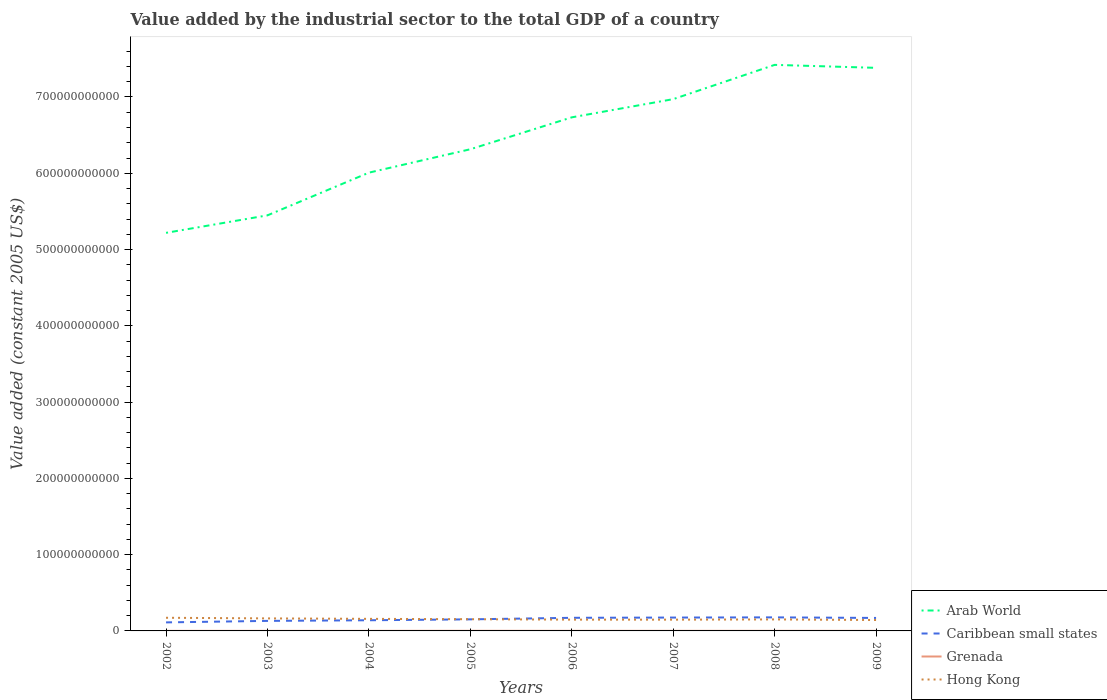Does the line corresponding to Arab World intersect with the line corresponding to Caribbean small states?
Keep it short and to the point. No. Is the number of lines equal to the number of legend labels?
Provide a short and direct response. Yes. Across all years, what is the maximum value added by the industrial sector in Hong Kong?
Keep it short and to the point. 1.43e+1. In which year was the value added by the industrial sector in Arab World maximum?
Keep it short and to the point. 2002. What is the total value added by the industrial sector in Hong Kong in the graph?
Make the answer very short. -3.16e+08. What is the difference between the highest and the second highest value added by the industrial sector in Caribbean small states?
Provide a succinct answer. 6.58e+09. Is the value added by the industrial sector in Grenada strictly greater than the value added by the industrial sector in Arab World over the years?
Offer a terse response. Yes. How many lines are there?
Your answer should be compact. 4. How many years are there in the graph?
Provide a succinct answer. 8. What is the difference between two consecutive major ticks on the Y-axis?
Ensure brevity in your answer.  1.00e+11. Are the values on the major ticks of Y-axis written in scientific E-notation?
Your answer should be compact. No. Does the graph contain grids?
Provide a short and direct response. No. Where does the legend appear in the graph?
Give a very brief answer. Bottom right. How many legend labels are there?
Keep it short and to the point. 4. What is the title of the graph?
Offer a very short reply. Value added by the industrial sector to the total GDP of a country. What is the label or title of the X-axis?
Provide a succinct answer. Years. What is the label or title of the Y-axis?
Ensure brevity in your answer.  Value added (constant 2005 US$). What is the Value added (constant 2005 US$) of Arab World in 2002?
Your answer should be compact. 5.22e+11. What is the Value added (constant 2005 US$) in Caribbean small states in 2002?
Ensure brevity in your answer.  1.12e+1. What is the Value added (constant 2005 US$) of Grenada in 2002?
Your answer should be compact. 8.91e+07. What is the Value added (constant 2005 US$) in Hong Kong in 2002?
Offer a very short reply. 1.72e+1. What is the Value added (constant 2005 US$) of Arab World in 2003?
Keep it short and to the point. 5.45e+11. What is the Value added (constant 2005 US$) in Caribbean small states in 2003?
Make the answer very short. 1.32e+1. What is the Value added (constant 2005 US$) of Grenada in 2003?
Provide a succinct answer. 1.01e+08. What is the Value added (constant 2005 US$) of Hong Kong in 2003?
Provide a succinct answer. 1.64e+1. What is the Value added (constant 2005 US$) in Arab World in 2004?
Offer a terse response. 6.01e+11. What is the Value added (constant 2005 US$) of Caribbean small states in 2004?
Ensure brevity in your answer.  1.40e+1. What is the Value added (constant 2005 US$) in Grenada in 2004?
Your answer should be compact. 1.01e+08. What is the Value added (constant 2005 US$) of Hong Kong in 2004?
Your answer should be compact. 1.58e+1. What is the Value added (constant 2005 US$) of Arab World in 2005?
Your response must be concise. 6.31e+11. What is the Value added (constant 2005 US$) of Caribbean small states in 2005?
Your answer should be very brief. 1.52e+1. What is the Value added (constant 2005 US$) of Grenada in 2005?
Ensure brevity in your answer.  1.59e+08. What is the Value added (constant 2005 US$) of Hong Kong in 2005?
Ensure brevity in your answer.  1.54e+1. What is the Value added (constant 2005 US$) in Arab World in 2006?
Your response must be concise. 6.73e+11. What is the Value added (constant 2005 US$) of Caribbean small states in 2006?
Give a very brief answer. 1.72e+1. What is the Value added (constant 2005 US$) in Grenada in 2006?
Your answer should be very brief. 1.25e+08. What is the Value added (constant 2005 US$) in Hong Kong in 2006?
Keep it short and to the point. 1.48e+1. What is the Value added (constant 2005 US$) of Arab World in 2007?
Offer a very short reply. 6.97e+11. What is the Value added (constant 2005 US$) of Caribbean small states in 2007?
Your answer should be very brief. 1.75e+1. What is the Value added (constant 2005 US$) in Grenada in 2007?
Ensure brevity in your answer.  1.23e+08. What is the Value added (constant 2005 US$) in Hong Kong in 2007?
Offer a very short reply. 1.48e+1. What is the Value added (constant 2005 US$) in Arab World in 2008?
Provide a succinct answer. 7.42e+11. What is the Value added (constant 2005 US$) of Caribbean small states in 2008?
Your answer should be very brief. 1.78e+1. What is the Value added (constant 2005 US$) of Grenada in 2008?
Your answer should be compact. 1.17e+08. What is the Value added (constant 2005 US$) of Hong Kong in 2008?
Ensure brevity in your answer.  1.51e+1. What is the Value added (constant 2005 US$) in Arab World in 2009?
Provide a succinct answer. 7.38e+11. What is the Value added (constant 2005 US$) of Caribbean small states in 2009?
Provide a succinct answer. 1.70e+1. What is the Value added (constant 2005 US$) of Grenada in 2009?
Ensure brevity in your answer.  9.46e+07. What is the Value added (constant 2005 US$) in Hong Kong in 2009?
Your response must be concise. 1.43e+1. Across all years, what is the maximum Value added (constant 2005 US$) in Arab World?
Give a very brief answer. 7.42e+11. Across all years, what is the maximum Value added (constant 2005 US$) of Caribbean small states?
Provide a short and direct response. 1.78e+1. Across all years, what is the maximum Value added (constant 2005 US$) in Grenada?
Keep it short and to the point. 1.59e+08. Across all years, what is the maximum Value added (constant 2005 US$) of Hong Kong?
Make the answer very short. 1.72e+1. Across all years, what is the minimum Value added (constant 2005 US$) of Arab World?
Make the answer very short. 5.22e+11. Across all years, what is the minimum Value added (constant 2005 US$) in Caribbean small states?
Offer a terse response. 1.12e+1. Across all years, what is the minimum Value added (constant 2005 US$) of Grenada?
Your answer should be compact. 8.91e+07. Across all years, what is the minimum Value added (constant 2005 US$) in Hong Kong?
Provide a short and direct response. 1.43e+1. What is the total Value added (constant 2005 US$) in Arab World in the graph?
Your response must be concise. 5.15e+12. What is the total Value added (constant 2005 US$) of Caribbean small states in the graph?
Your answer should be very brief. 1.23e+11. What is the total Value added (constant 2005 US$) of Grenada in the graph?
Keep it short and to the point. 9.10e+08. What is the total Value added (constant 2005 US$) in Hong Kong in the graph?
Provide a short and direct response. 1.24e+11. What is the difference between the Value added (constant 2005 US$) in Arab World in 2002 and that in 2003?
Your answer should be compact. -2.29e+1. What is the difference between the Value added (constant 2005 US$) of Caribbean small states in 2002 and that in 2003?
Provide a succinct answer. -1.97e+09. What is the difference between the Value added (constant 2005 US$) in Grenada in 2002 and that in 2003?
Provide a short and direct response. -1.23e+07. What is the difference between the Value added (constant 2005 US$) of Hong Kong in 2002 and that in 2003?
Give a very brief answer. 8.12e+08. What is the difference between the Value added (constant 2005 US$) of Arab World in 2002 and that in 2004?
Provide a succinct answer. -7.89e+1. What is the difference between the Value added (constant 2005 US$) in Caribbean small states in 2002 and that in 2004?
Give a very brief answer. -2.80e+09. What is the difference between the Value added (constant 2005 US$) in Grenada in 2002 and that in 2004?
Ensure brevity in your answer.  -1.16e+07. What is the difference between the Value added (constant 2005 US$) of Hong Kong in 2002 and that in 2004?
Your answer should be very brief. 1.42e+09. What is the difference between the Value added (constant 2005 US$) in Arab World in 2002 and that in 2005?
Make the answer very short. -1.10e+11. What is the difference between the Value added (constant 2005 US$) in Caribbean small states in 2002 and that in 2005?
Make the answer very short. -3.99e+09. What is the difference between the Value added (constant 2005 US$) of Grenada in 2002 and that in 2005?
Your answer should be compact. -6.98e+07. What is the difference between the Value added (constant 2005 US$) of Hong Kong in 2002 and that in 2005?
Ensure brevity in your answer.  1.88e+09. What is the difference between the Value added (constant 2005 US$) in Arab World in 2002 and that in 2006?
Make the answer very short. -1.51e+11. What is the difference between the Value added (constant 2005 US$) of Caribbean small states in 2002 and that in 2006?
Make the answer very short. -6.01e+09. What is the difference between the Value added (constant 2005 US$) of Grenada in 2002 and that in 2006?
Your answer should be compact. -3.59e+07. What is the difference between the Value added (constant 2005 US$) of Hong Kong in 2002 and that in 2006?
Provide a short and direct response. 2.43e+09. What is the difference between the Value added (constant 2005 US$) in Arab World in 2002 and that in 2007?
Give a very brief answer. -1.75e+11. What is the difference between the Value added (constant 2005 US$) in Caribbean small states in 2002 and that in 2007?
Your answer should be compact. -6.33e+09. What is the difference between the Value added (constant 2005 US$) in Grenada in 2002 and that in 2007?
Your answer should be very brief. -3.36e+07. What is the difference between the Value added (constant 2005 US$) of Hong Kong in 2002 and that in 2007?
Keep it short and to the point. 2.47e+09. What is the difference between the Value added (constant 2005 US$) of Arab World in 2002 and that in 2008?
Offer a very short reply. -2.20e+11. What is the difference between the Value added (constant 2005 US$) in Caribbean small states in 2002 and that in 2008?
Your answer should be very brief. -6.58e+09. What is the difference between the Value added (constant 2005 US$) of Grenada in 2002 and that in 2008?
Give a very brief answer. -2.82e+07. What is the difference between the Value added (constant 2005 US$) in Hong Kong in 2002 and that in 2008?
Your answer should be compact. 2.16e+09. What is the difference between the Value added (constant 2005 US$) of Arab World in 2002 and that in 2009?
Give a very brief answer. -2.16e+11. What is the difference between the Value added (constant 2005 US$) of Caribbean small states in 2002 and that in 2009?
Provide a short and direct response. -5.84e+09. What is the difference between the Value added (constant 2005 US$) of Grenada in 2002 and that in 2009?
Give a very brief answer. -5.55e+06. What is the difference between the Value added (constant 2005 US$) of Hong Kong in 2002 and that in 2009?
Your answer should be compact. 2.94e+09. What is the difference between the Value added (constant 2005 US$) of Arab World in 2003 and that in 2004?
Make the answer very short. -5.60e+1. What is the difference between the Value added (constant 2005 US$) in Caribbean small states in 2003 and that in 2004?
Give a very brief answer. -8.28e+08. What is the difference between the Value added (constant 2005 US$) in Grenada in 2003 and that in 2004?
Keep it short and to the point. 6.55e+05. What is the difference between the Value added (constant 2005 US$) in Hong Kong in 2003 and that in 2004?
Keep it short and to the point. 6.04e+08. What is the difference between the Value added (constant 2005 US$) in Arab World in 2003 and that in 2005?
Keep it short and to the point. -8.67e+1. What is the difference between the Value added (constant 2005 US$) in Caribbean small states in 2003 and that in 2005?
Keep it short and to the point. -2.02e+09. What is the difference between the Value added (constant 2005 US$) of Grenada in 2003 and that in 2005?
Offer a very short reply. -5.76e+07. What is the difference between the Value added (constant 2005 US$) of Hong Kong in 2003 and that in 2005?
Provide a short and direct response. 1.07e+09. What is the difference between the Value added (constant 2005 US$) of Arab World in 2003 and that in 2006?
Provide a short and direct response. -1.28e+11. What is the difference between the Value added (constant 2005 US$) in Caribbean small states in 2003 and that in 2006?
Offer a terse response. -4.04e+09. What is the difference between the Value added (constant 2005 US$) in Grenada in 2003 and that in 2006?
Your answer should be compact. -2.36e+07. What is the difference between the Value added (constant 2005 US$) of Hong Kong in 2003 and that in 2006?
Offer a very short reply. 1.61e+09. What is the difference between the Value added (constant 2005 US$) of Arab World in 2003 and that in 2007?
Your answer should be compact. -1.52e+11. What is the difference between the Value added (constant 2005 US$) in Caribbean small states in 2003 and that in 2007?
Give a very brief answer. -4.36e+09. What is the difference between the Value added (constant 2005 US$) of Grenada in 2003 and that in 2007?
Keep it short and to the point. -2.13e+07. What is the difference between the Value added (constant 2005 US$) in Hong Kong in 2003 and that in 2007?
Make the answer very short. 1.66e+09. What is the difference between the Value added (constant 2005 US$) in Arab World in 2003 and that in 2008?
Provide a short and direct response. -1.97e+11. What is the difference between the Value added (constant 2005 US$) of Caribbean small states in 2003 and that in 2008?
Your answer should be compact. -4.61e+09. What is the difference between the Value added (constant 2005 US$) in Grenada in 2003 and that in 2008?
Your answer should be compact. -1.59e+07. What is the difference between the Value added (constant 2005 US$) in Hong Kong in 2003 and that in 2008?
Offer a terse response. 1.35e+09. What is the difference between the Value added (constant 2005 US$) of Arab World in 2003 and that in 2009?
Make the answer very short. -1.93e+11. What is the difference between the Value added (constant 2005 US$) of Caribbean small states in 2003 and that in 2009?
Offer a terse response. -3.86e+09. What is the difference between the Value added (constant 2005 US$) in Grenada in 2003 and that in 2009?
Offer a terse response. 6.71e+06. What is the difference between the Value added (constant 2005 US$) of Hong Kong in 2003 and that in 2009?
Ensure brevity in your answer.  2.13e+09. What is the difference between the Value added (constant 2005 US$) of Arab World in 2004 and that in 2005?
Keep it short and to the point. -3.07e+1. What is the difference between the Value added (constant 2005 US$) in Caribbean small states in 2004 and that in 2005?
Make the answer very short. -1.19e+09. What is the difference between the Value added (constant 2005 US$) in Grenada in 2004 and that in 2005?
Give a very brief answer. -5.82e+07. What is the difference between the Value added (constant 2005 US$) in Hong Kong in 2004 and that in 2005?
Your answer should be compact. 4.62e+08. What is the difference between the Value added (constant 2005 US$) of Arab World in 2004 and that in 2006?
Provide a short and direct response. -7.25e+1. What is the difference between the Value added (constant 2005 US$) in Caribbean small states in 2004 and that in 2006?
Ensure brevity in your answer.  -3.21e+09. What is the difference between the Value added (constant 2005 US$) of Grenada in 2004 and that in 2006?
Make the answer very short. -2.43e+07. What is the difference between the Value added (constant 2005 US$) of Hong Kong in 2004 and that in 2006?
Ensure brevity in your answer.  1.01e+09. What is the difference between the Value added (constant 2005 US$) of Arab World in 2004 and that in 2007?
Make the answer very short. -9.64e+1. What is the difference between the Value added (constant 2005 US$) in Caribbean small states in 2004 and that in 2007?
Provide a succinct answer. -3.53e+09. What is the difference between the Value added (constant 2005 US$) in Grenada in 2004 and that in 2007?
Keep it short and to the point. -2.20e+07. What is the difference between the Value added (constant 2005 US$) in Hong Kong in 2004 and that in 2007?
Offer a very short reply. 1.06e+09. What is the difference between the Value added (constant 2005 US$) in Arab World in 2004 and that in 2008?
Make the answer very short. -1.41e+11. What is the difference between the Value added (constant 2005 US$) in Caribbean small states in 2004 and that in 2008?
Offer a very short reply. -3.78e+09. What is the difference between the Value added (constant 2005 US$) in Grenada in 2004 and that in 2008?
Your response must be concise. -1.66e+07. What is the difference between the Value added (constant 2005 US$) in Hong Kong in 2004 and that in 2008?
Provide a short and direct response. 7.42e+08. What is the difference between the Value added (constant 2005 US$) of Arab World in 2004 and that in 2009?
Your response must be concise. -1.37e+11. What is the difference between the Value added (constant 2005 US$) of Caribbean small states in 2004 and that in 2009?
Offer a very short reply. -3.04e+09. What is the difference between the Value added (constant 2005 US$) in Grenada in 2004 and that in 2009?
Make the answer very short. 6.06e+06. What is the difference between the Value added (constant 2005 US$) of Hong Kong in 2004 and that in 2009?
Provide a succinct answer. 1.53e+09. What is the difference between the Value added (constant 2005 US$) of Arab World in 2005 and that in 2006?
Ensure brevity in your answer.  -4.18e+1. What is the difference between the Value added (constant 2005 US$) of Caribbean small states in 2005 and that in 2006?
Offer a terse response. -2.02e+09. What is the difference between the Value added (constant 2005 US$) in Grenada in 2005 and that in 2006?
Keep it short and to the point. 3.39e+07. What is the difference between the Value added (constant 2005 US$) of Hong Kong in 2005 and that in 2006?
Make the answer very short. 5.48e+08. What is the difference between the Value added (constant 2005 US$) of Arab World in 2005 and that in 2007?
Provide a short and direct response. -6.57e+1. What is the difference between the Value added (constant 2005 US$) in Caribbean small states in 2005 and that in 2007?
Your answer should be compact. -2.34e+09. What is the difference between the Value added (constant 2005 US$) in Grenada in 2005 and that in 2007?
Your answer should be very brief. 3.62e+07. What is the difference between the Value added (constant 2005 US$) in Hong Kong in 2005 and that in 2007?
Offer a terse response. 5.95e+08. What is the difference between the Value added (constant 2005 US$) of Arab World in 2005 and that in 2008?
Your response must be concise. -1.11e+11. What is the difference between the Value added (constant 2005 US$) in Caribbean small states in 2005 and that in 2008?
Ensure brevity in your answer.  -2.59e+09. What is the difference between the Value added (constant 2005 US$) in Grenada in 2005 and that in 2008?
Keep it short and to the point. 4.16e+07. What is the difference between the Value added (constant 2005 US$) in Hong Kong in 2005 and that in 2008?
Provide a succinct answer. 2.79e+08. What is the difference between the Value added (constant 2005 US$) in Arab World in 2005 and that in 2009?
Provide a short and direct response. -1.07e+11. What is the difference between the Value added (constant 2005 US$) of Caribbean small states in 2005 and that in 2009?
Provide a short and direct response. -1.85e+09. What is the difference between the Value added (constant 2005 US$) of Grenada in 2005 and that in 2009?
Offer a very short reply. 6.43e+07. What is the difference between the Value added (constant 2005 US$) in Hong Kong in 2005 and that in 2009?
Your answer should be very brief. 1.06e+09. What is the difference between the Value added (constant 2005 US$) in Arab World in 2006 and that in 2007?
Provide a succinct answer. -2.39e+1. What is the difference between the Value added (constant 2005 US$) of Caribbean small states in 2006 and that in 2007?
Provide a short and direct response. -3.19e+08. What is the difference between the Value added (constant 2005 US$) of Grenada in 2006 and that in 2007?
Make the answer very short. 2.30e+06. What is the difference between the Value added (constant 2005 US$) in Hong Kong in 2006 and that in 2007?
Your answer should be compact. 4.72e+07. What is the difference between the Value added (constant 2005 US$) of Arab World in 2006 and that in 2008?
Offer a terse response. -6.88e+1. What is the difference between the Value added (constant 2005 US$) in Caribbean small states in 2006 and that in 2008?
Ensure brevity in your answer.  -5.71e+08. What is the difference between the Value added (constant 2005 US$) in Grenada in 2006 and that in 2008?
Offer a very short reply. 7.68e+06. What is the difference between the Value added (constant 2005 US$) of Hong Kong in 2006 and that in 2008?
Your answer should be very brief. -2.69e+08. What is the difference between the Value added (constant 2005 US$) of Arab World in 2006 and that in 2009?
Make the answer very short. -6.49e+1. What is the difference between the Value added (constant 2005 US$) of Caribbean small states in 2006 and that in 2009?
Your response must be concise. 1.75e+08. What is the difference between the Value added (constant 2005 US$) of Grenada in 2006 and that in 2009?
Your answer should be compact. 3.03e+07. What is the difference between the Value added (constant 2005 US$) in Hong Kong in 2006 and that in 2009?
Your response must be concise. 5.16e+08. What is the difference between the Value added (constant 2005 US$) of Arab World in 2007 and that in 2008?
Give a very brief answer. -4.49e+1. What is the difference between the Value added (constant 2005 US$) of Caribbean small states in 2007 and that in 2008?
Give a very brief answer. -2.52e+08. What is the difference between the Value added (constant 2005 US$) of Grenada in 2007 and that in 2008?
Provide a short and direct response. 5.39e+06. What is the difference between the Value added (constant 2005 US$) of Hong Kong in 2007 and that in 2008?
Offer a very short reply. -3.16e+08. What is the difference between the Value added (constant 2005 US$) of Arab World in 2007 and that in 2009?
Offer a terse response. -4.10e+1. What is the difference between the Value added (constant 2005 US$) in Caribbean small states in 2007 and that in 2009?
Your answer should be very brief. 4.93e+08. What is the difference between the Value added (constant 2005 US$) in Grenada in 2007 and that in 2009?
Keep it short and to the point. 2.80e+07. What is the difference between the Value added (constant 2005 US$) of Hong Kong in 2007 and that in 2009?
Offer a terse response. 4.69e+08. What is the difference between the Value added (constant 2005 US$) in Arab World in 2008 and that in 2009?
Offer a very short reply. 3.89e+09. What is the difference between the Value added (constant 2005 US$) of Caribbean small states in 2008 and that in 2009?
Provide a short and direct response. 7.46e+08. What is the difference between the Value added (constant 2005 US$) in Grenada in 2008 and that in 2009?
Offer a very short reply. 2.27e+07. What is the difference between the Value added (constant 2005 US$) in Hong Kong in 2008 and that in 2009?
Make the answer very short. 7.85e+08. What is the difference between the Value added (constant 2005 US$) of Arab World in 2002 and the Value added (constant 2005 US$) of Caribbean small states in 2003?
Give a very brief answer. 5.09e+11. What is the difference between the Value added (constant 2005 US$) of Arab World in 2002 and the Value added (constant 2005 US$) of Grenada in 2003?
Give a very brief answer. 5.22e+11. What is the difference between the Value added (constant 2005 US$) in Arab World in 2002 and the Value added (constant 2005 US$) in Hong Kong in 2003?
Your answer should be compact. 5.05e+11. What is the difference between the Value added (constant 2005 US$) in Caribbean small states in 2002 and the Value added (constant 2005 US$) in Grenada in 2003?
Ensure brevity in your answer.  1.11e+1. What is the difference between the Value added (constant 2005 US$) in Caribbean small states in 2002 and the Value added (constant 2005 US$) in Hong Kong in 2003?
Offer a very short reply. -5.24e+09. What is the difference between the Value added (constant 2005 US$) of Grenada in 2002 and the Value added (constant 2005 US$) of Hong Kong in 2003?
Give a very brief answer. -1.63e+1. What is the difference between the Value added (constant 2005 US$) of Arab World in 2002 and the Value added (constant 2005 US$) of Caribbean small states in 2004?
Offer a very short reply. 5.08e+11. What is the difference between the Value added (constant 2005 US$) in Arab World in 2002 and the Value added (constant 2005 US$) in Grenada in 2004?
Provide a succinct answer. 5.22e+11. What is the difference between the Value added (constant 2005 US$) in Arab World in 2002 and the Value added (constant 2005 US$) in Hong Kong in 2004?
Keep it short and to the point. 5.06e+11. What is the difference between the Value added (constant 2005 US$) of Caribbean small states in 2002 and the Value added (constant 2005 US$) of Grenada in 2004?
Make the answer very short. 1.11e+1. What is the difference between the Value added (constant 2005 US$) in Caribbean small states in 2002 and the Value added (constant 2005 US$) in Hong Kong in 2004?
Your response must be concise. -4.63e+09. What is the difference between the Value added (constant 2005 US$) in Grenada in 2002 and the Value added (constant 2005 US$) in Hong Kong in 2004?
Make the answer very short. -1.57e+1. What is the difference between the Value added (constant 2005 US$) in Arab World in 2002 and the Value added (constant 2005 US$) in Caribbean small states in 2005?
Your answer should be very brief. 5.07e+11. What is the difference between the Value added (constant 2005 US$) in Arab World in 2002 and the Value added (constant 2005 US$) in Grenada in 2005?
Provide a short and direct response. 5.22e+11. What is the difference between the Value added (constant 2005 US$) in Arab World in 2002 and the Value added (constant 2005 US$) in Hong Kong in 2005?
Give a very brief answer. 5.07e+11. What is the difference between the Value added (constant 2005 US$) in Caribbean small states in 2002 and the Value added (constant 2005 US$) in Grenada in 2005?
Provide a succinct answer. 1.10e+1. What is the difference between the Value added (constant 2005 US$) of Caribbean small states in 2002 and the Value added (constant 2005 US$) of Hong Kong in 2005?
Your response must be concise. -4.17e+09. What is the difference between the Value added (constant 2005 US$) in Grenada in 2002 and the Value added (constant 2005 US$) in Hong Kong in 2005?
Offer a very short reply. -1.53e+1. What is the difference between the Value added (constant 2005 US$) of Arab World in 2002 and the Value added (constant 2005 US$) of Caribbean small states in 2006?
Give a very brief answer. 5.05e+11. What is the difference between the Value added (constant 2005 US$) of Arab World in 2002 and the Value added (constant 2005 US$) of Grenada in 2006?
Keep it short and to the point. 5.22e+11. What is the difference between the Value added (constant 2005 US$) in Arab World in 2002 and the Value added (constant 2005 US$) in Hong Kong in 2006?
Offer a very short reply. 5.07e+11. What is the difference between the Value added (constant 2005 US$) of Caribbean small states in 2002 and the Value added (constant 2005 US$) of Grenada in 2006?
Provide a short and direct response. 1.11e+1. What is the difference between the Value added (constant 2005 US$) in Caribbean small states in 2002 and the Value added (constant 2005 US$) in Hong Kong in 2006?
Provide a short and direct response. -3.62e+09. What is the difference between the Value added (constant 2005 US$) of Grenada in 2002 and the Value added (constant 2005 US$) of Hong Kong in 2006?
Provide a succinct answer. -1.47e+1. What is the difference between the Value added (constant 2005 US$) in Arab World in 2002 and the Value added (constant 2005 US$) in Caribbean small states in 2007?
Your response must be concise. 5.04e+11. What is the difference between the Value added (constant 2005 US$) in Arab World in 2002 and the Value added (constant 2005 US$) in Grenada in 2007?
Keep it short and to the point. 5.22e+11. What is the difference between the Value added (constant 2005 US$) of Arab World in 2002 and the Value added (constant 2005 US$) of Hong Kong in 2007?
Keep it short and to the point. 5.07e+11. What is the difference between the Value added (constant 2005 US$) in Caribbean small states in 2002 and the Value added (constant 2005 US$) in Grenada in 2007?
Ensure brevity in your answer.  1.11e+1. What is the difference between the Value added (constant 2005 US$) of Caribbean small states in 2002 and the Value added (constant 2005 US$) of Hong Kong in 2007?
Your answer should be compact. -3.58e+09. What is the difference between the Value added (constant 2005 US$) in Grenada in 2002 and the Value added (constant 2005 US$) in Hong Kong in 2007?
Your response must be concise. -1.47e+1. What is the difference between the Value added (constant 2005 US$) in Arab World in 2002 and the Value added (constant 2005 US$) in Caribbean small states in 2008?
Keep it short and to the point. 5.04e+11. What is the difference between the Value added (constant 2005 US$) of Arab World in 2002 and the Value added (constant 2005 US$) of Grenada in 2008?
Make the answer very short. 5.22e+11. What is the difference between the Value added (constant 2005 US$) of Arab World in 2002 and the Value added (constant 2005 US$) of Hong Kong in 2008?
Provide a succinct answer. 5.07e+11. What is the difference between the Value added (constant 2005 US$) of Caribbean small states in 2002 and the Value added (constant 2005 US$) of Grenada in 2008?
Your answer should be compact. 1.11e+1. What is the difference between the Value added (constant 2005 US$) in Caribbean small states in 2002 and the Value added (constant 2005 US$) in Hong Kong in 2008?
Keep it short and to the point. -3.89e+09. What is the difference between the Value added (constant 2005 US$) of Grenada in 2002 and the Value added (constant 2005 US$) of Hong Kong in 2008?
Ensure brevity in your answer.  -1.50e+1. What is the difference between the Value added (constant 2005 US$) in Arab World in 2002 and the Value added (constant 2005 US$) in Caribbean small states in 2009?
Offer a very short reply. 5.05e+11. What is the difference between the Value added (constant 2005 US$) of Arab World in 2002 and the Value added (constant 2005 US$) of Grenada in 2009?
Ensure brevity in your answer.  5.22e+11. What is the difference between the Value added (constant 2005 US$) in Arab World in 2002 and the Value added (constant 2005 US$) in Hong Kong in 2009?
Your response must be concise. 5.08e+11. What is the difference between the Value added (constant 2005 US$) of Caribbean small states in 2002 and the Value added (constant 2005 US$) of Grenada in 2009?
Offer a terse response. 1.11e+1. What is the difference between the Value added (constant 2005 US$) of Caribbean small states in 2002 and the Value added (constant 2005 US$) of Hong Kong in 2009?
Provide a short and direct response. -3.11e+09. What is the difference between the Value added (constant 2005 US$) of Grenada in 2002 and the Value added (constant 2005 US$) of Hong Kong in 2009?
Offer a very short reply. -1.42e+1. What is the difference between the Value added (constant 2005 US$) of Arab World in 2003 and the Value added (constant 2005 US$) of Caribbean small states in 2004?
Your answer should be very brief. 5.31e+11. What is the difference between the Value added (constant 2005 US$) of Arab World in 2003 and the Value added (constant 2005 US$) of Grenada in 2004?
Your answer should be very brief. 5.45e+11. What is the difference between the Value added (constant 2005 US$) of Arab World in 2003 and the Value added (constant 2005 US$) of Hong Kong in 2004?
Offer a very short reply. 5.29e+11. What is the difference between the Value added (constant 2005 US$) of Caribbean small states in 2003 and the Value added (constant 2005 US$) of Grenada in 2004?
Provide a short and direct response. 1.31e+1. What is the difference between the Value added (constant 2005 US$) in Caribbean small states in 2003 and the Value added (constant 2005 US$) in Hong Kong in 2004?
Your response must be concise. -2.66e+09. What is the difference between the Value added (constant 2005 US$) of Grenada in 2003 and the Value added (constant 2005 US$) of Hong Kong in 2004?
Give a very brief answer. -1.57e+1. What is the difference between the Value added (constant 2005 US$) of Arab World in 2003 and the Value added (constant 2005 US$) of Caribbean small states in 2005?
Offer a very short reply. 5.30e+11. What is the difference between the Value added (constant 2005 US$) of Arab World in 2003 and the Value added (constant 2005 US$) of Grenada in 2005?
Offer a terse response. 5.45e+11. What is the difference between the Value added (constant 2005 US$) in Arab World in 2003 and the Value added (constant 2005 US$) in Hong Kong in 2005?
Give a very brief answer. 5.29e+11. What is the difference between the Value added (constant 2005 US$) in Caribbean small states in 2003 and the Value added (constant 2005 US$) in Grenada in 2005?
Your response must be concise. 1.30e+1. What is the difference between the Value added (constant 2005 US$) in Caribbean small states in 2003 and the Value added (constant 2005 US$) in Hong Kong in 2005?
Ensure brevity in your answer.  -2.20e+09. What is the difference between the Value added (constant 2005 US$) in Grenada in 2003 and the Value added (constant 2005 US$) in Hong Kong in 2005?
Your response must be concise. -1.53e+1. What is the difference between the Value added (constant 2005 US$) in Arab World in 2003 and the Value added (constant 2005 US$) in Caribbean small states in 2006?
Make the answer very short. 5.28e+11. What is the difference between the Value added (constant 2005 US$) in Arab World in 2003 and the Value added (constant 2005 US$) in Grenada in 2006?
Provide a succinct answer. 5.45e+11. What is the difference between the Value added (constant 2005 US$) of Arab World in 2003 and the Value added (constant 2005 US$) of Hong Kong in 2006?
Your answer should be very brief. 5.30e+11. What is the difference between the Value added (constant 2005 US$) of Caribbean small states in 2003 and the Value added (constant 2005 US$) of Grenada in 2006?
Your response must be concise. 1.30e+1. What is the difference between the Value added (constant 2005 US$) of Caribbean small states in 2003 and the Value added (constant 2005 US$) of Hong Kong in 2006?
Keep it short and to the point. -1.65e+09. What is the difference between the Value added (constant 2005 US$) of Grenada in 2003 and the Value added (constant 2005 US$) of Hong Kong in 2006?
Keep it short and to the point. -1.47e+1. What is the difference between the Value added (constant 2005 US$) in Arab World in 2003 and the Value added (constant 2005 US$) in Caribbean small states in 2007?
Give a very brief answer. 5.27e+11. What is the difference between the Value added (constant 2005 US$) in Arab World in 2003 and the Value added (constant 2005 US$) in Grenada in 2007?
Your response must be concise. 5.45e+11. What is the difference between the Value added (constant 2005 US$) in Arab World in 2003 and the Value added (constant 2005 US$) in Hong Kong in 2007?
Provide a short and direct response. 5.30e+11. What is the difference between the Value added (constant 2005 US$) of Caribbean small states in 2003 and the Value added (constant 2005 US$) of Grenada in 2007?
Offer a terse response. 1.30e+1. What is the difference between the Value added (constant 2005 US$) in Caribbean small states in 2003 and the Value added (constant 2005 US$) in Hong Kong in 2007?
Keep it short and to the point. -1.60e+09. What is the difference between the Value added (constant 2005 US$) of Grenada in 2003 and the Value added (constant 2005 US$) of Hong Kong in 2007?
Make the answer very short. -1.47e+1. What is the difference between the Value added (constant 2005 US$) in Arab World in 2003 and the Value added (constant 2005 US$) in Caribbean small states in 2008?
Provide a short and direct response. 5.27e+11. What is the difference between the Value added (constant 2005 US$) of Arab World in 2003 and the Value added (constant 2005 US$) of Grenada in 2008?
Keep it short and to the point. 5.45e+11. What is the difference between the Value added (constant 2005 US$) in Arab World in 2003 and the Value added (constant 2005 US$) in Hong Kong in 2008?
Offer a very short reply. 5.30e+11. What is the difference between the Value added (constant 2005 US$) of Caribbean small states in 2003 and the Value added (constant 2005 US$) of Grenada in 2008?
Provide a succinct answer. 1.30e+1. What is the difference between the Value added (constant 2005 US$) in Caribbean small states in 2003 and the Value added (constant 2005 US$) in Hong Kong in 2008?
Make the answer very short. -1.92e+09. What is the difference between the Value added (constant 2005 US$) in Grenada in 2003 and the Value added (constant 2005 US$) in Hong Kong in 2008?
Offer a terse response. -1.50e+1. What is the difference between the Value added (constant 2005 US$) of Arab World in 2003 and the Value added (constant 2005 US$) of Caribbean small states in 2009?
Provide a short and direct response. 5.28e+11. What is the difference between the Value added (constant 2005 US$) of Arab World in 2003 and the Value added (constant 2005 US$) of Grenada in 2009?
Your answer should be very brief. 5.45e+11. What is the difference between the Value added (constant 2005 US$) in Arab World in 2003 and the Value added (constant 2005 US$) in Hong Kong in 2009?
Your answer should be compact. 5.31e+11. What is the difference between the Value added (constant 2005 US$) in Caribbean small states in 2003 and the Value added (constant 2005 US$) in Grenada in 2009?
Your response must be concise. 1.31e+1. What is the difference between the Value added (constant 2005 US$) in Caribbean small states in 2003 and the Value added (constant 2005 US$) in Hong Kong in 2009?
Give a very brief answer. -1.13e+09. What is the difference between the Value added (constant 2005 US$) of Grenada in 2003 and the Value added (constant 2005 US$) of Hong Kong in 2009?
Your answer should be compact. -1.42e+1. What is the difference between the Value added (constant 2005 US$) of Arab World in 2004 and the Value added (constant 2005 US$) of Caribbean small states in 2005?
Keep it short and to the point. 5.86e+11. What is the difference between the Value added (constant 2005 US$) in Arab World in 2004 and the Value added (constant 2005 US$) in Grenada in 2005?
Your response must be concise. 6.01e+11. What is the difference between the Value added (constant 2005 US$) in Arab World in 2004 and the Value added (constant 2005 US$) in Hong Kong in 2005?
Provide a short and direct response. 5.85e+11. What is the difference between the Value added (constant 2005 US$) in Caribbean small states in 2004 and the Value added (constant 2005 US$) in Grenada in 2005?
Your response must be concise. 1.38e+1. What is the difference between the Value added (constant 2005 US$) of Caribbean small states in 2004 and the Value added (constant 2005 US$) of Hong Kong in 2005?
Your answer should be compact. -1.37e+09. What is the difference between the Value added (constant 2005 US$) of Grenada in 2004 and the Value added (constant 2005 US$) of Hong Kong in 2005?
Keep it short and to the point. -1.53e+1. What is the difference between the Value added (constant 2005 US$) in Arab World in 2004 and the Value added (constant 2005 US$) in Caribbean small states in 2006?
Your answer should be very brief. 5.84e+11. What is the difference between the Value added (constant 2005 US$) of Arab World in 2004 and the Value added (constant 2005 US$) of Grenada in 2006?
Offer a terse response. 6.01e+11. What is the difference between the Value added (constant 2005 US$) of Arab World in 2004 and the Value added (constant 2005 US$) of Hong Kong in 2006?
Your answer should be compact. 5.86e+11. What is the difference between the Value added (constant 2005 US$) in Caribbean small states in 2004 and the Value added (constant 2005 US$) in Grenada in 2006?
Your answer should be compact. 1.39e+1. What is the difference between the Value added (constant 2005 US$) in Caribbean small states in 2004 and the Value added (constant 2005 US$) in Hong Kong in 2006?
Give a very brief answer. -8.22e+08. What is the difference between the Value added (constant 2005 US$) in Grenada in 2004 and the Value added (constant 2005 US$) in Hong Kong in 2006?
Make the answer very short. -1.47e+1. What is the difference between the Value added (constant 2005 US$) in Arab World in 2004 and the Value added (constant 2005 US$) in Caribbean small states in 2007?
Offer a very short reply. 5.83e+11. What is the difference between the Value added (constant 2005 US$) of Arab World in 2004 and the Value added (constant 2005 US$) of Grenada in 2007?
Your answer should be very brief. 6.01e+11. What is the difference between the Value added (constant 2005 US$) of Arab World in 2004 and the Value added (constant 2005 US$) of Hong Kong in 2007?
Your answer should be very brief. 5.86e+11. What is the difference between the Value added (constant 2005 US$) in Caribbean small states in 2004 and the Value added (constant 2005 US$) in Grenada in 2007?
Your response must be concise. 1.39e+1. What is the difference between the Value added (constant 2005 US$) in Caribbean small states in 2004 and the Value added (constant 2005 US$) in Hong Kong in 2007?
Keep it short and to the point. -7.75e+08. What is the difference between the Value added (constant 2005 US$) of Grenada in 2004 and the Value added (constant 2005 US$) of Hong Kong in 2007?
Ensure brevity in your answer.  -1.47e+1. What is the difference between the Value added (constant 2005 US$) in Arab World in 2004 and the Value added (constant 2005 US$) in Caribbean small states in 2008?
Your answer should be compact. 5.83e+11. What is the difference between the Value added (constant 2005 US$) in Arab World in 2004 and the Value added (constant 2005 US$) in Grenada in 2008?
Offer a very short reply. 6.01e+11. What is the difference between the Value added (constant 2005 US$) of Arab World in 2004 and the Value added (constant 2005 US$) of Hong Kong in 2008?
Provide a succinct answer. 5.86e+11. What is the difference between the Value added (constant 2005 US$) in Caribbean small states in 2004 and the Value added (constant 2005 US$) in Grenada in 2008?
Your answer should be very brief. 1.39e+1. What is the difference between the Value added (constant 2005 US$) in Caribbean small states in 2004 and the Value added (constant 2005 US$) in Hong Kong in 2008?
Provide a short and direct response. -1.09e+09. What is the difference between the Value added (constant 2005 US$) in Grenada in 2004 and the Value added (constant 2005 US$) in Hong Kong in 2008?
Your response must be concise. -1.50e+1. What is the difference between the Value added (constant 2005 US$) of Arab World in 2004 and the Value added (constant 2005 US$) of Caribbean small states in 2009?
Your answer should be very brief. 5.84e+11. What is the difference between the Value added (constant 2005 US$) of Arab World in 2004 and the Value added (constant 2005 US$) of Grenada in 2009?
Your answer should be very brief. 6.01e+11. What is the difference between the Value added (constant 2005 US$) in Arab World in 2004 and the Value added (constant 2005 US$) in Hong Kong in 2009?
Make the answer very short. 5.87e+11. What is the difference between the Value added (constant 2005 US$) of Caribbean small states in 2004 and the Value added (constant 2005 US$) of Grenada in 2009?
Your answer should be compact. 1.39e+1. What is the difference between the Value added (constant 2005 US$) in Caribbean small states in 2004 and the Value added (constant 2005 US$) in Hong Kong in 2009?
Provide a short and direct response. -3.06e+08. What is the difference between the Value added (constant 2005 US$) of Grenada in 2004 and the Value added (constant 2005 US$) of Hong Kong in 2009?
Provide a succinct answer. -1.42e+1. What is the difference between the Value added (constant 2005 US$) in Arab World in 2005 and the Value added (constant 2005 US$) in Caribbean small states in 2006?
Provide a succinct answer. 6.14e+11. What is the difference between the Value added (constant 2005 US$) of Arab World in 2005 and the Value added (constant 2005 US$) of Grenada in 2006?
Your response must be concise. 6.31e+11. What is the difference between the Value added (constant 2005 US$) in Arab World in 2005 and the Value added (constant 2005 US$) in Hong Kong in 2006?
Give a very brief answer. 6.17e+11. What is the difference between the Value added (constant 2005 US$) in Caribbean small states in 2005 and the Value added (constant 2005 US$) in Grenada in 2006?
Keep it short and to the point. 1.50e+1. What is the difference between the Value added (constant 2005 US$) of Caribbean small states in 2005 and the Value added (constant 2005 US$) of Hong Kong in 2006?
Provide a short and direct response. 3.65e+08. What is the difference between the Value added (constant 2005 US$) in Grenada in 2005 and the Value added (constant 2005 US$) in Hong Kong in 2006?
Give a very brief answer. -1.46e+1. What is the difference between the Value added (constant 2005 US$) in Arab World in 2005 and the Value added (constant 2005 US$) in Caribbean small states in 2007?
Your answer should be very brief. 6.14e+11. What is the difference between the Value added (constant 2005 US$) of Arab World in 2005 and the Value added (constant 2005 US$) of Grenada in 2007?
Your response must be concise. 6.31e+11. What is the difference between the Value added (constant 2005 US$) in Arab World in 2005 and the Value added (constant 2005 US$) in Hong Kong in 2007?
Provide a succinct answer. 6.17e+11. What is the difference between the Value added (constant 2005 US$) in Caribbean small states in 2005 and the Value added (constant 2005 US$) in Grenada in 2007?
Offer a very short reply. 1.51e+1. What is the difference between the Value added (constant 2005 US$) of Caribbean small states in 2005 and the Value added (constant 2005 US$) of Hong Kong in 2007?
Provide a succinct answer. 4.12e+08. What is the difference between the Value added (constant 2005 US$) of Grenada in 2005 and the Value added (constant 2005 US$) of Hong Kong in 2007?
Ensure brevity in your answer.  -1.46e+1. What is the difference between the Value added (constant 2005 US$) of Arab World in 2005 and the Value added (constant 2005 US$) of Caribbean small states in 2008?
Provide a short and direct response. 6.14e+11. What is the difference between the Value added (constant 2005 US$) in Arab World in 2005 and the Value added (constant 2005 US$) in Grenada in 2008?
Offer a very short reply. 6.31e+11. What is the difference between the Value added (constant 2005 US$) of Arab World in 2005 and the Value added (constant 2005 US$) of Hong Kong in 2008?
Your response must be concise. 6.16e+11. What is the difference between the Value added (constant 2005 US$) of Caribbean small states in 2005 and the Value added (constant 2005 US$) of Grenada in 2008?
Ensure brevity in your answer.  1.51e+1. What is the difference between the Value added (constant 2005 US$) of Caribbean small states in 2005 and the Value added (constant 2005 US$) of Hong Kong in 2008?
Your answer should be very brief. 9.62e+07. What is the difference between the Value added (constant 2005 US$) in Grenada in 2005 and the Value added (constant 2005 US$) in Hong Kong in 2008?
Your answer should be compact. -1.49e+1. What is the difference between the Value added (constant 2005 US$) in Arab World in 2005 and the Value added (constant 2005 US$) in Caribbean small states in 2009?
Your answer should be very brief. 6.14e+11. What is the difference between the Value added (constant 2005 US$) of Arab World in 2005 and the Value added (constant 2005 US$) of Grenada in 2009?
Give a very brief answer. 6.31e+11. What is the difference between the Value added (constant 2005 US$) of Arab World in 2005 and the Value added (constant 2005 US$) of Hong Kong in 2009?
Give a very brief answer. 6.17e+11. What is the difference between the Value added (constant 2005 US$) of Caribbean small states in 2005 and the Value added (constant 2005 US$) of Grenada in 2009?
Ensure brevity in your answer.  1.51e+1. What is the difference between the Value added (constant 2005 US$) in Caribbean small states in 2005 and the Value added (constant 2005 US$) in Hong Kong in 2009?
Offer a terse response. 8.81e+08. What is the difference between the Value added (constant 2005 US$) of Grenada in 2005 and the Value added (constant 2005 US$) of Hong Kong in 2009?
Your answer should be compact. -1.41e+1. What is the difference between the Value added (constant 2005 US$) in Arab World in 2006 and the Value added (constant 2005 US$) in Caribbean small states in 2007?
Provide a succinct answer. 6.56e+11. What is the difference between the Value added (constant 2005 US$) of Arab World in 2006 and the Value added (constant 2005 US$) of Grenada in 2007?
Your answer should be very brief. 6.73e+11. What is the difference between the Value added (constant 2005 US$) of Arab World in 2006 and the Value added (constant 2005 US$) of Hong Kong in 2007?
Offer a very short reply. 6.59e+11. What is the difference between the Value added (constant 2005 US$) of Caribbean small states in 2006 and the Value added (constant 2005 US$) of Grenada in 2007?
Provide a succinct answer. 1.71e+1. What is the difference between the Value added (constant 2005 US$) in Caribbean small states in 2006 and the Value added (constant 2005 US$) in Hong Kong in 2007?
Provide a succinct answer. 2.44e+09. What is the difference between the Value added (constant 2005 US$) in Grenada in 2006 and the Value added (constant 2005 US$) in Hong Kong in 2007?
Your response must be concise. -1.46e+1. What is the difference between the Value added (constant 2005 US$) in Arab World in 2006 and the Value added (constant 2005 US$) in Caribbean small states in 2008?
Keep it short and to the point. 6.56e+11. What is the difference between the Value added (constant 2005 US$) in Arab World in 2006 and the Value added (constant 2005 US$) in Grenada in 2008?
Your response must be concise. 6.73e+11. What is the difference between the Value added (constant 2005 US$) of Arab World in 2006 and the Value added (constant 2005 US$) of Hong Kong in 2008?
Provide a short and direct response. 6.58e+11. What is the difference between the Value added (constant 2005 US$) of Caribbean small states in 2006 and the Value added (constant 2005 US$) of Grenada in 2008?
Provide a succinct answer. 1.71e+1. What is the difference between the Value added (constant 2005 US$) in Caribbean small states in 2006 and the Value added (constant 2005 US$) in Hong Kong in 2008?
Give a very brief answer. 2.12e+09. What is the difference between the Value added (constant 2005 US$) of Grenada in 2006 and the Value added (constant 2005 US$) of Hong Kong in 2008?
Provide a short and direct response. -1.50e+1. What is the difference between the Value added (constant 2005 US$) in Arab World in 2006 and the Value added (constant 2005 US$) in Caribbean small states in 2009?
Your answer should be very brief. 6.56e+11. What is the difference between the Value added (constant 2005 US$) of Arab World in 2006 and the Value added (constant 2005 US$) of Grenada in 2009?
Make the answer very short. 6.73e+11. What is the difference between the Value added (constant 2005 US$) in Arab World in 2006 and the Value added (constant 2005 US$) in Hong Kong in 2009?
Your response must be concise. 6.59e+11. What is the difference between the Value added (constant 2005 US$) of Caribbean small states in 2006 and the Value added (constant 2005 US$) of Grenada in 2009?
Keep it short and to the point. 1.71e+1. What is the difference between the Value added (constant 2005 US$) of Caribbean small states in 2006 and the Value added (constant 2005 US$) of Hong Kong in 2009?
Ensure brevity in your answer.  2.90e+09. What is the difference between the Value added (constant 2005 US$) in Grenada in 2006 and the Value added (constant 2005 US$) in Hong Kong in 2009?
Give a very brief answer. -1.42e+1. What is the difference between the Value added (constant 2005 US$) of Arab World in 2007 and the Value added (constant 2005 US$) of Caribbean small states in 2008?
Ensure brevity in your answer.  6.79e+11. What is the difference between the Value added (constant 2005 US$) of Arab World in 2007 and the Value added (constant 2005 US$) of Grenada in 2008?
Your response must be concise. 6.97e+11. What is the difference between the Value added (constant 2005 US$) of Arab World in 2007 and the Value added (constant 2005 US$) of Hong Kong in 2008?
Your response must be concise. 6.82e+11. What is the difference between the Value added (constant 2005 US$) of Caribbean small states in 2007 and the Value added (constant 2005 US$) of Grenada in 2008?
Ensure brevity in your answer.  1.74e+1. What is the difference between the Value added (constant 2005 US$) in Caribbean small states in 2007 and the Value added (constant 2005 US$) in Hong Kong in 2008?
Provide a short and direct response. 2.44e+09. What is the difference between the Value added (constant 2005 US$) in Grenada in 2007 and the Value added (constant 2005 US$) in Hong Kong in 2008?
Give a very brief answer. -1.50e+1. What is the difference between the Value added (constant 2005 US$) of Arab World in 2007 and the Value added (constant 2005 US$) of Caribbean small states in 2009?
Your answer should be very brief. 6.80e+11. What is the difference between the Value added (constant 2005 US$) in Arab World in 2007 and the Value added (constant 2005 US$) in Grenada in 2009?
Your answer should be very brief. 6.97e+11. What is the difference between the Value added (constant 2005 US$) of Arab World in 2007 and the Value added (constant 2005 US$) of Hong Kong in 2009?
Your answer should be compact. 6.83e+11. What is the difference between the Value added (constant 2005 US$) of Caribbean small states in 2007 and the Value added (constant 2005 US$) of Grenada in 2009?
Your answer should be compact. 1.74e+1. What is the difference between the Value added (constant 2005 US$) of Caribbean small states in 2007 and the Value added (constant 2005 US$) of Hong Kong in 2009?
Offer a terse response. 3.22e+09. What is the difference between the Value added (constant 2005 US$) in Grenada in 2007 and the Value added (constant 2005 US$) in Hong Kong in 2009?
Keep it short and to the point. -1.42e+1. What is the difference between the Value added (constant 2005 US$) of Arab World in 2008 and the Value added (constant 2005 US$) of Caribbean small states in 2009?
Ensure brevity in your answer.  7.25e+11. What is the difference between the Value added (constant 2005 US$) of Arab World in 2008 and the Value added (constant 2005 US$) of Grenada in 2009?
Provide a short and direct response. 7.42e+11. What is the difference between the Value added (constant 2005 US$) in Arab World in 2008 and the Value added (constant 2005 US$) in Hong Kong in 2009?
Your response must be concise. 7.28e+11. What is the difference between the Value added (constant 2005 US$) in Caribbean small states in 2008 and the Value added (constant 2005 US$) in Grenada in 2009?
Ensure brevity in your answer.  1.77e+1. What is the difference between the Value added (constant 2005 US$) in Caribbean small states in 2008 and the Value added (constant 2005 US$) in Hong Kong in 2009?
Make the answer very short. 3.48e+09. What is the difference between the Value added (constant 2005 US$) in Grenada in 2008 and the Value added (constant 2005 US$) in Hong Kong in 2009?
Give a very brief answer. -1.42e+1. What is the average Value added (constant 2005 US$) of Arab World per year?
Make the answer very short. 6.44e+11. What is the average Value added (constant 2005 US$) in Caribbean small states per year?
Provide a short and direct response. 1.54e+1. What is the average Value added (constant 2005 US$) of Grenada per year?
Your response must be concise. 1.14e+08. What is the average Value added (constant 2005 US$) in Hong Kong per year?
Provide a short and direct response. 1.55e+1. In the year 2002, what is the difference between the Value added (constant 2005 US$) in Arab World and Value added (constant 2005 US$) in Caribbean small states?
Provide a short and direct response. 5.11e+11. In the year 2002, what is the difference between the Value added (constant 2005 US$) of Arab World and Value added (constant 2005 US$) of Grenada?
Give a very brief answer. 5.22e+11. In the year 2002, what is the difference between the Value added (constant 2005 US$) of Arab World and Value added (constant 2005 US$) of Hong Kong?
Make the answer very short. 5.05e+11. In the year 2002, what is the difference between the Value added (constant 2005 US$) in Caribbean small states and Value added (constant 2005 US$) in Grenada?
Your answer should be compact. 1.11e+1. In the year 2002, what is the difference between the Value added (constant 2005 US$) of Caribbean small states and Value added (constant 2005 US$) of Hong Kong?
Your answer should be very brief. -6.05e+09. In the year 2002, what is the difference between the Value added (constant 2005 US$) of Grenada and Value added (constant 2005 US$) of Hong Kong?
Keep it short and to the point. -1.71e+1. In the year 2003, what is the difference between the Value added (constant 2005 US$) of Arab World and Value added (constant 2005 US$) of Caribbean small states?
Give a very brief answer. 5.32e+11. In the year 2003, what is the difference between the Value added (constant 2005 US$) of Arab World and Value added (constant 2005 US$) of Grenada?
Your answer should be very brief. 5.45e+11. In the year 2003, what is the difference between the Value added (constant 2005 US$) of Arab World and Value added (constant 2005 US$) of Hong Kong?
Your answer should be very brief. 5.28e+11. In the year 2003, what is the difference between the Value added (constant 2005 US$) in Caribbean small states and Value added (constant 2005 US$) in Grenada?
Offer a very short reply. 1.31e+1. In the year 2003, what is the difference between the Value added (constant 2005 US$) of Caribbean small states and Value added (constant 2005 US$) of Hong Kong?
Your answer should be very brief. -3.26e+09. In the year 2003, what is the difference between the Value added (constant 2005 US$) of Grenada and Value added (constant 2005 US$) of Hong Kong?
Your answer should be very brief. -1.63e+1. In the year 2004, what is the difference between the Value added (constant 2005 US$) in Arab World and Value added (constant 2005 US$) in Caribbean small states?
Your answer should be very brief. 5.87e+11. In the year 2004, what is the difference between the Value added (constant 2005 US$) in Arab World and Value added (constant 2005 US$) in Grenada?
Make the answer very short. 6.01e+11. In the year 2004, what is the difference between the Value added (constant 2005 US$) of Arab World and Value added (constant 2005 US$) of Hong Kong?
Provide a succinct answer. 5.85e+11. In the year 2004, what is the difference between the Value added (constant 2005 US$) of Caribbean small states and Value added (constant 2005 US$) of Grenada?
Ensure brevity in your answer.  1.39e+1. In the year 2004, what is the difference between the Value added (constant 2005 US$) of Caribbean small states and Value added (constant 2005 US$) of Hong Kong?
Offer a terse response. -1.83e+09. In the year 2004, what is the difference between the Value added (constant 2005 US$) of Grenada and Value added (constant 2005 US$) of Hong Kong?
Offer a terse response. -1.57e+1. In the year 2005, what is the difference between the Value added (constant 2005 US$) of Arab World and Value added (constant 2005 US$) of Caribbean small states?
Ensure brevity in your answer.  6.16e+11. In the year 2005, what is the difference between the Value added (constant 2005 US$) of Arab World and Value added (constant 2005 US$) of Grenada?
Offer a terse response. 6.31e+11. In the year 2005, what is the difference between the Value added (constant 2005 US$) in Arab World and Value added (constant 2005 US$) in Hong Kong?
Ensure brevity in your answer.  6.16e+11. In the year 2005, what is the difference between the Value added (constant 2005 US$) in Caribbean small states and Value added (constant 2005 US$) in Grenada?
Provide a succinct answer. 1.50e+1. In the year 2005, what is the difference between the Value added (constant 2005 US$) in Caribbean small states and Value added (constant 2005 US$) in Hong Kong?
Offer a very short reply. -1.83e+08. In the year 2005, what is the difference between the Value added (constant 2005 US$) in Grenada and Value added (constant 2005 US$) in Hong Kong?
Keep it short and to the point. -1.52e+1. In the year 2006, what is the difference between the Value added (constant 2005 US$) in Arab World and Value added (constant 2005 US$) in Caribbean small states?
Your answer should be compact. 6.56e+11. In the year 2006, what is the difference between the Value added (constant 2005 US$) of Arab World and Value added (constant 2005 US$) of Grenada?
Ensure brevity in your answer.  6.73e+11. In the year 2006, what is the difference between the Value added (constant 2005 US$) of Arab World and Value added (constant 2005 US$) of Hong Kong?
Your response must be concise. 6.59e+11. In the year 2006, what is the difference between the Value added (constant 2005 US$) of Caribbean small states and Value added (constant 2005 US$) of Grenada?
Provide a succinct answer. 1.71e+1. In the year 2006, what is the difference between the Value added (constant 2005 US$) of Caribbean small states and Value added (constant 2005 US$) of Hong Kong?
Make the answer very short. 2.39e+09. In the year 2006, what is the difference between the Value added (constant 2005 US$) in Grenada and Value added (constant 2005 US$) in Hong Kong?
Your answer should be compact. -1.47e+1. In the year 2007, what is the difference between the Value added (constant 2005 US$) in Arab World and Value added (constant 2005 US$) in Caribbean small states?
Make the answer very short. 6.80e+11. In the year 2007, what is the difference between the Value added (constant 2005 US$) of Arab World and Value added (constant 2005 US$) of Grenada?
Give a very brief answer. 6.97e+11. In the year 2007, what is the difference between the Value added (constant 2005 US$) of Arab World and Value added (constant 2005 US$) of Hong Kong?
Make the answer very short. 6.82e+11. In the year 2007, what is the difference between the Value added (constant 2005 US$) of Caribbean small states and Value added (constant 2005 US$) of Grenada?
Your answer should be compact. 1.74e+1. In the year 2007, what is the difference between the Value added (constant 2005 US$) in Caribbean small states and Value added (constant 2005 US$) in Hong Kong?
Make the answer very short. 2.75e+09. In the year 2007, what is the difference between the Value added (constant 2005 US$) in Grenada and Value added (constant 2005 US$) in Hong Kong?
Provide a succinct answer. -1.46e+1. In the year 2008, what is the difference between the Value added (constant 2005 US$) of Arab World and Value added (constant 2005 US$) of Caribbean small states?
Make the answer very short. 7.24e+11. In the year 2008, what is the difference between the Value added (constant 2005 US$) in Arab World and Value added (constant 2005 US$) in Grenada?
Your answer should be compact. 7.42e+11. In the year 2008, what is the difference between the Value added (constant 2005 US$) in Arab World and Value added (constant 2005 US$) in Hong Kong?
Make the answer very short. 7.27e+11. In the year 2008, what is the difference between the Value added (constant 2005 US$) in Caribbean small states and Value added (constant 2005 US$) in Grenada?
Keep it short and to the point. 1.77e+1. In the year 2008, what is the difference between the Value added (constant 2005 US$) of Caribbean small states and Value added (constant 2005 US$) of Hong Kong?
Keep it short and to the point. 2.69e+09. In the year 2008, what is the difference between the Value added (constant 2005 US$) of Grenada and Value added (constant 2005 US$) of Hong Kong?
Your answer should be very brief. -1.50e+1. In the year 2009, what is the difference between the Value added (constant 2005 US$) of Arab World and Value added (constant 2005 US$) of Caribbean small states?
Make the answer very short. 7.21e+11. In the year 2009, what is the difference between the Value added (constant 2005 US$) in Arab World and Value added (constant 2005 US$) in Grenada?
Provide a succinct answer. 7.38e+11. In the year 2009, what is the difference between the Value added (constant 2005 US$) in Arab World and Value added (constant 2005 US$) in Hong Kong?
Provide a short and direct response. 7.24e+11. In the year 2009, what is the difference between the Value added (constant 2005 US$) of Caribbean small states and Value added (constant 2005 US$) of Grenada?
Your answer should be very brief. 1.69e+1. In the year 2009, what is the difference between the Value added (constant 2005 US$) of Caribbean small states and Value added (constant 2005 US$) of Hong Kong?
Your answer should be compact. 2.73e+09. In the year 2009, what is the difference between the Value added (constant 2005 US$) of Grenada and Value added (constant 2005 US$) of Hong Kong?
Make the answer very short. -1.42e+1. What is the ratio of the Value added (constant 2005 US$) in Arab World in 2002 to that in 2003?
Your answer should be compact. 0.96. What is the ratio of the Value added (constant 2005 US$) in Grenada in 2002 to that in 2003?
Your answer should be very brief. 0.88. What is the ratio of the Value added (constant 2005 US$) of Hong Kong in 2002 to that in 2003?
Your answer should be compact. 1.05. What is the ratio of the Value added (constant 2005 US$) in Arab World in 2002 to that in 2004?
Your answer should be very brief. 0.87. What is the ratio of the Value added (constant 2005 US$) in Caribbean small states in 2002 to that in 2004?
Provide a succinct answer. 0.8. What is the ratio of the Value added (constant 2005 US$) of Grenada in 2002 to that in 2004?
Your answer should be very brief. 0.88. What is the ratio of the Value added (constant 2005 US$) of Hong Kong in 2002 to that in 2004?
Provide a short and direct response. 1.09. What is the ratio of the Value added (constant 2005 US$) of Arab World in 2002 to that in 2005?
Offer a terse response. 0.83. What is the ratio of the Value added (constant 2005 US$) of Caribbean small states in 2002 to that in 2005?
Provide a short and direct response. 0.74. What is the ratio of the Value added (constant 2005 US$) of Grenada in 2002 to that in 2005?
Your response must be concise. 0.56. What is the ratio of the Value added (constant 2005 US$) of Hong Kong in 2002 to that in 2005?
Offer a very short reply. 1.12. What is the ratio of the Value added (constant 2005 US$) in Arab World in 2002 to that in 2006?
Your response must be concise. 0.78. What is the ratio of the Value added (constant 2005 US$) of Caribbean small states in 2002 to that in 2006?
Provide a succinct answer. 0.65. What is the ratio of the Value added (constant 2005 US$) in Grenada in 2002 to that in 2006?
Ensure brevity in your answer.  0.71. What is the ratio of the Value added (constant 2005 US$) of Hong Kong in 2002 to that in 2006?
Your answer should be very brief. 1.16. What is the ratio of the Value added (constant 2005 US$) of Arab World in 2002 to that in 2007?
Your answer should be compact. 0.75. What is the ratio of the Value added (constant 2005 US$) of Caribbean small states in 2002 to that in 2007?
Provide a short and direct response. 0.64. What is the ratio of the Value added (constant 2005 US$) of Grenada in 2002 to that in 2007?
Offer a terse response. 0.73. What is the ratio of the Value added (constant 2005 US$) in Hong Kong in 2002 to that in 2007?
Keep it short and to the point. 1.17. What is the ratio of the Value added (constant 2005 US$) in Arab World in 2002 to that in 2008?
Provide a short and direct response. 0.7. What is the ratio of the Value added (constant 2005 US$) in Caribbean small states in 2002 to that in 2008?
Ensure brevity in your answer.  0.63. What is the ratio of the Value added (constant 2005 US$) of Grenada in 2002 to that in 2008?
Your response must be concise. 0.76. What is the ratio of the Value added (constant 2005 US$) in Hong Kong in 2002 to that in 2008?
Give a very brief answer. 1.14. What is the ratio of the Value added (constant 2005 US$) of Arab World in 2002 to that in 2009?
Your answer should be compact. 0.71. What is the ratio of the Value added (constant 2005 US$) of Caribbean small states in 2002 to that in 2009?
Provide a short and direct response. 0.66. What is the ratio of the Value added (constant 2005 US$) of Grenada in 2002 to that in 2009?
Provide a short and direct response. 0.94. What is the ratio of the Value added (constant 2005 US$) of Hong Kong in 2002 to that in 2009?
Provide a short and direct response. 1.21. What is the ratio of the Value added (constant 2005 US$) of Arab World in 2003 to that in 2004?
Provide a short and direct response. 0.91. What is the ratio of the Value added (constant 2005 US$) of Caribbean small states in 2003 to that in 2004?
Ensure brevity in your answer.  0.94. What is the ratio of the Value added (constant 2005 US$) in Hong Kong in 2003 to that in 2004?
Give a very brief answer. 1.04. What is the ratio of the Value added (constant 2005 US$) in Arab World in 2003 to that in 2005?
Ensure brevity in your answer.  0.86. What is the ratio of the Value added (constant 2005 US$) of Caribbean small states in 2003 to that in 2005?
Your response must be concise. 0.87. What is the ratio of the Value added (constant 2005 US$) of Grenada in 2003 to that in 2005?
Give a very brief answer. 0.64. What is the ratio of the Value added (constant 2005 US$) of Hong Kong in 2003 to that in 2005?
Ensure brevity in your answer.  1.07. What is the ratio of the Value added (constant 2005 US$) in Arab World in 2003 to that in 2006?
Offer a very short reply. 0.81. What is the ratio of the Value added (constant 2005 US$) of Caribbean small states in 2003 to that in 2006?
Keep it short and to the point. 0.77. What is the ratio of the Value added (constant 2005 US$) of Grenada in 2003 to that in 2006?
Your answer should be very brief. 0.81. What is the ratio of the Value added (constant 2005 US$) of Hong Kong in 2003 to that in 2006?
Provide a short and direct response. 1.11. What is the ratio of the Value added (constant 2005 US$) in Arab World in 2003 to that in 2007?
Provide a succinct answer. 0.78. What is the ratio of the Value added (constant 2005 US$) of Caribbean small states in 2003 to that in 2007?
Offer a very short reply. 0.75. What is the ratio of the Value added (constant 2005 US$) of Grenada in 2003 to that in 2007?
Your answer should be very brief. 0.83. What is the ratio of the Value added (constant 2005 US$) in Hong Kong in 2003 to that in 2007?
Provide a short and direct response. 1.11. What is the ratio of the Value added (constant 2005 US$) of Arab World in 2003 to that in 2008?
Provide a succinct answer. 0.73. What is the ratio of the Value added (constant 2005 US$) of Caribbean small states in 2003 to that in 2008?
Provide a succinct answer. 0.74. What is the ratio of the Value added (constant 2005 US$) of Grenada in 2003 to that in 2008?
Your answer should be compact. 0.86. What is the ratio of the Value added (constant 2005 US$) in Hong Kong in 2003 to that in 2008?
Your answer should be compact. 1.09. What is the ratio of the Value added (constant 2005 US$) of Arab World in 2003 to that in 2009?
Your answer should be very brief. 0.74. What is the ratio of the Value added (constant 2005 US$) of Caribbean small states in 2003 to that in 2009?
Your answer should be compact. 0.77. What is the ratio of the Value added (constant 2005 US$) in Grenada in 2003 to that in 2009?
Give a very brief answer. 1.07. What is the ratio of the Value added (constant 2005 US$) of Hong Kong in 2003 to that in 2009?
Offer a very short reply. 1.15. What is the ratio of the Value added (constant 2005 US$) in Arab World in 2004 to that in 2005?
Your answer should be compact. 0.95. What is the ratio of the Value added (constant 2005 US$) of Caribbean small states in 2004 to that in 2005?
Ensure brevity in your answer.  0.92. What is the ratio of the Value added (constant 2005 US$) in Grenada in 2004 to that in 2005?
Keep it short and to the point. 0.63. What is the ratio of the Value added (constant 2005 US$) in Hong Kong in 2004 to that in 2005?
Offer a very short reply. 1.03. What is the ratio of the Value added (constant 2005 US$) in Arab World in 2004 to that in 2006?
Give a very brief answer. 0.89. What is the ratio of the Value added (constant 2005 US$) of Caribbean small states in 2004 to that in 2006?
Provide a short and direct response. 0.81. What is the ratio of the Value added (constant 2005 US$) in Grenada in 2004 to that in 2006?
Keep it short and to the point. 0.81. What is the ratio of the Value added (constant 2005 US$) in Hong Kong in 2004 to that in 2006?
Provide a short and direct response. 1.07. What is the ratio of the Value added (constant 2005 US$) in Arab World in 2004 to that in 2007?
Offer a terse response. 0.86. What is the ratio of the Value added (constant 2005 US$) in Caribbean small states in 2004 to that in 2007?
Your answer should be very brief. 0.8. What is the ratio of the Value added (constant 2005 US$) in Grenada in 2004 to that in 2007?
Give a very brief answer. 0.82. What is the ratio of the Value added (constant 2005 US$) in Hong Kong in 2004 to that in 2007?
Keep it short and to the point. 1.07. What is the ratio of the Value added (constant 2005 US$) of Arab World in 2004 to that in 2008?
Ensure brevity in your answer.  0.81. What is the ratio of the Value added (constant 2005 US$) of Caribbean small states in 2004 to that in 2008?
Keep it short and to the point. 0.79. What is the ratio of the Value added (constant 2005 US$) of Grenada in 2004 to that in 2008?
Make the answer very short. 0.86. What is the ratio of the Value added (constant 2005 US$) of Hong Kong in 2004 to that in 2008?
Keep it short and to the point. 1.05. What is the ratio of the Value added (constant 2005 US$) of Arab World in 2004 to that in 2009?
Ensure brevity in your answer.  0.81. What is the ratio of the Value added (constant 2005 US$) of Caribbean small states in 2004 to that in 2009?
Ensure brevity in your answer.  0.82. What is the ratio of the Value added (constant 2005 US$) of Grenada in 2004 to that in 2009?
Your answer should be very brief. 1.06. What is the ratio of the Value added (constant 2005 US$) in Hong Kong in 2004 to that in 2009?
Your answer should be compact. 1.11. What is the ratio of the Value added (constant 2005 US$) of Arab World in 2005 to that in 2006?
Offer a very short reply. 0.94. What is the ratio of the Value added (constant 2005 US$) of Caribbean small states in 2005 to that in 2006?
Give a very brief answer. 0.88. What is the ratio of the Value added (constant 2005 US$) in Grenada in 2005 to that in 2006?
Your response must be concise. 1.27. What is the ratio of the Value added (constant 2005 US$) of Arab World in 2005 to that in 2007?
Offer a terse response. 0.91. What is the ratio of the Value added (constant 2005 US$) in Caribbean small states in 2005 to that in 2007?
Your response must be concise. 0.87. What is the ratio of the Value added (constant 2005 US$) of Grenada in 2005 to that in 2007?
Your response must be concise. 1.3. What is the ratio of the Value added (constant 2005 US$) of Hong Kong in 2005 to that in 2007?
Offer a terse response. 1.04. What is the ratio of the Value added (constant 2005 US$) of Arab World in 2005 to that in 2008?
Offer a very short reply. 0.85. What is the ratio of the Value added (constant 2005 US$) of Caribbean small states in 2005 to that in 2008?
Keep it short and to the point. 0.85. What is the ratio of the Value added (constant 2005 US$) in Grenada in 2005 to that in 2008?
Give a very brief answer. 1.35. What is the ratio of the Value added (constant 2005 US$) in Hong Kong in 2005 to that in 2008?
Ensure brevity in your answer.  1.02. What is the ratio of the Value added (constant 2005 US$) in Arab World in 2005 to that in 2009?
Ensure brevity in your answer.  0.86. What is the ratio of the Value added (constant 2005 US$) in Caribbean small states in 2005 to that in 2009?
Offer a very short reply. 0.89. What is the ratio of the Value added (constant 2005 US$) in Grenada in 2005 to that in 2009?
Your answer should be very brief. 1.68. What is the ratio of the Value added (constant 2005 US$) in Hong Kong in 2005 to that in 2009?
Keep it short and to the point. 1.07. What is the ratio of the Value added (constant 2005 US$) of Arab World in 2006 to that in 2007?
Provide a short and direct response. 0.97. What is the ratio of the Value added (constant 2005 US$) of Caribbean small states in 2006 to that in 2007?
Keep it short and to the point. 0.98. What is the ratio of the Value added (constant 2005 US$) of Grenada in 2006 to that in 2007?
Make the answer very short. 1.02. What is the ratio of the Value added (constant 2005 US$) in Arab World in 2006 to that in 2008?
Your answer should be compact. 0.91. What is the ratio of the Value added (constant 2005 US$) in Caribbean small states in 2006 to that in 2008?
Offer a very short reply. 0.97. What is the ratio of the Value added (constant 2005 US$) in Grenada in 2006 to that in 2008?
Provide a succinct answer. 1.07. What is the ratio of the Value added (constant 2005 US$) of Hong Kong in 2006 to that in 2008?
Give a very brief answer. 0.98. What is the ratio of the Value added (constant 2005 US$) of Arab World in 2006 to that in 2009?
Your answer should be very brief. 0.91. What is the ratio of the Value added (constant 2005 US$) in Caribbean small states in 2006 to that in 2009?
Give a very brief answer. 1.01. What is the ratio of the Value added (constant 2005 US$) of Grenada in 2006 to that in 2009?
Provide a short and direct response. 1.32. What is the ratio of the Value added (constant 2005 US$) of Hong Kong in 2006 to that in 2009?
Make the answer very short. 1.04. What is the ratio of the Value added (constant 2005 US$) in Arab World in 2007 to that in 2008?
Make the answer very short. 0.94. What is the ratio of the Value added (constant 2005 US$) of Caribbean small states in 2007 to that in 2008?
Provide a succinct answer. 0.99. What is the ratio of the Value added (constant 2005 US$) of Grenada in 2007 to that in 2008?
Your answer should be compact. 1.05. What is the ratio of the Value added (constant 2005 US$) of Hong Kong in 2007 to that in 2008?
Provide a succinct answer. 0.98. What is the ratio of the Value added (constant 2005 US$) in Grenada in 2007 to that in 2009?
Your response must be concise. 1.3. What is the ratio of the Value added (constant 2005 US$) in Hong Kong in 2007 to that in 2009?
Provide a succinct answer. 1.03. What is the ratio of the Value added (constant 2005 US$) in Arab World in 2008 to that in 2009?
Give a very brief answer. 1.01. What is the ratio of the Value added (constant 2005 US$) of Caribbean small states in 2008 to that in 2009?
Provide a succinct answer. 1.04. What is the ratio of the Value added (constant 2005 US$) in Grenada in 2008 to that in 2009?
Keep it short and to the point. 1.24. What is the ratio of the Value added (constant 2005 US$) of Hong Kong in 2008 to that in 2009?
Offer a terse response. 1.05. What is the difference between the highest and the second highest Value added (constant 2005 US$) in Arab World?
Ensure brevity in your answer.  3.89e+09. What is the difference between the highest and the second highest Value added (constant 2005 US$) of Caribbean small states?
Offer a terse response. 2.52e+08. What is the difference between the highest and the second highest Value added (constant 2005 US$) in Grenada?
Provide a succinct answer. 3.39e+07. What is the difference between the highest and the second highest Value added (constant 2005 US$) in Hong Kong?
Your answer should be compact. 8.12e+08. What is the difference between the highest and the lowest Value added (constant 2005 US$) of Arab World?
Make the answer very short. 2.20e+11. What is the difference between the highest and the lowest Value added (constant 2005 US$) of Caribbean small states?
Give a very brief answer. 6.58e+09. What is the difference between the highest and the lowest Value added (constant 2005 US$) of Grenada?
Keep it short and to the point. 6.98e+07. What is the difference between the highest and the lowest Value added (constant 2005 US$) in Hong Kong?
Offer a terse response. 2.94e+09. 